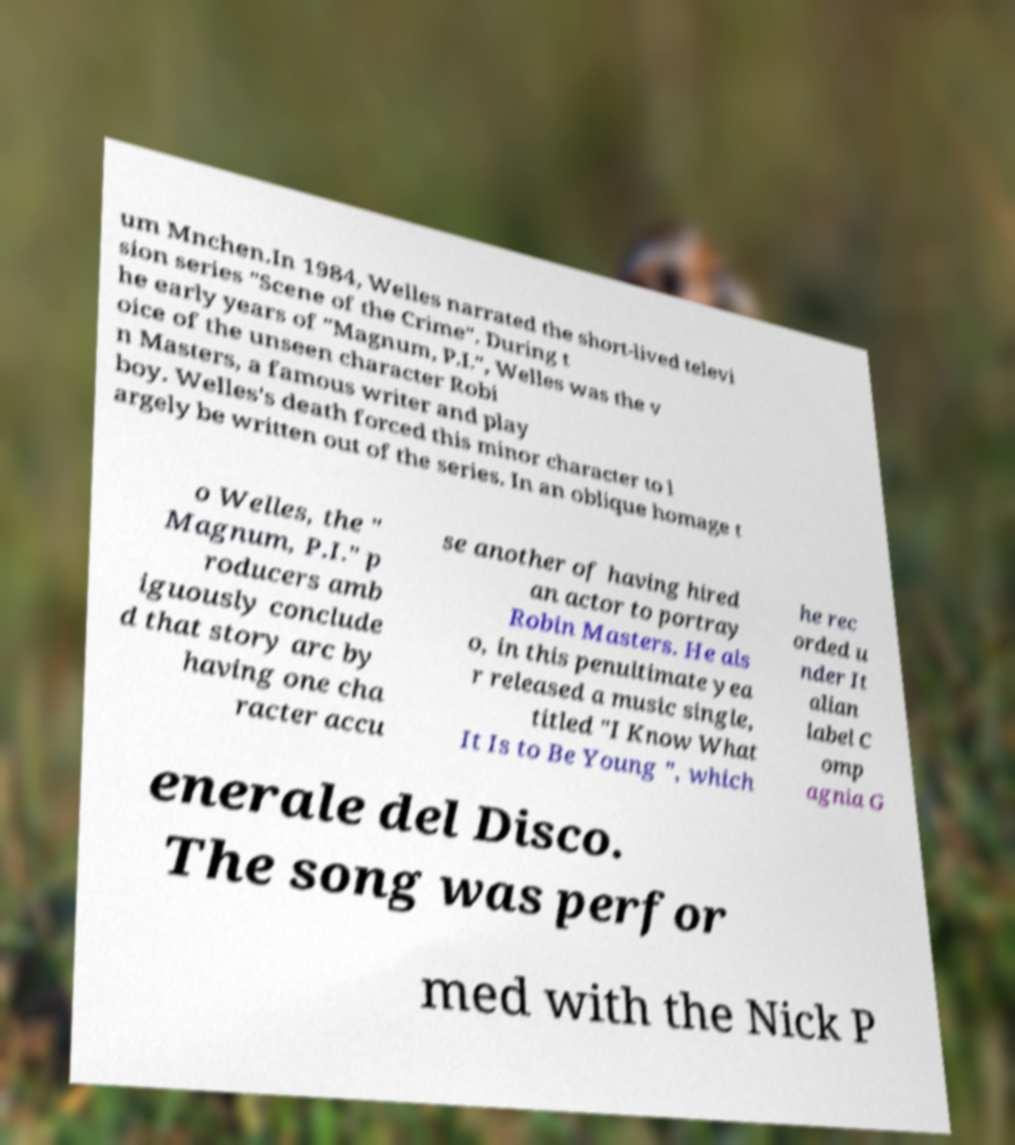For documentation purposes, I need the text within this image transcribed. Could you provide that? um Mnchen.In 1984, Welles narrated the short-lived televi sion series "Scene of the Crime". During t he early years of "Magnum, P.I.", Welles was the v oice of the unseen character Robi n Masters, a famous writer and play boy. Welles's death forced this minor character to l argely be written out of the series. In an oblique homage t o Welles, the " Magnum, P.I." p roducers amb iguously conclude d that story arc by having one cha racter accu se another of having hired an actor to portray Robin Masters. He als o, in this penultimate yea r released a music single, titled "I Know What It Is to Be Young ", which he rec orded u nder It alian label C omp agnia G enerale del Disco. The song was perfor med with the Nick P 